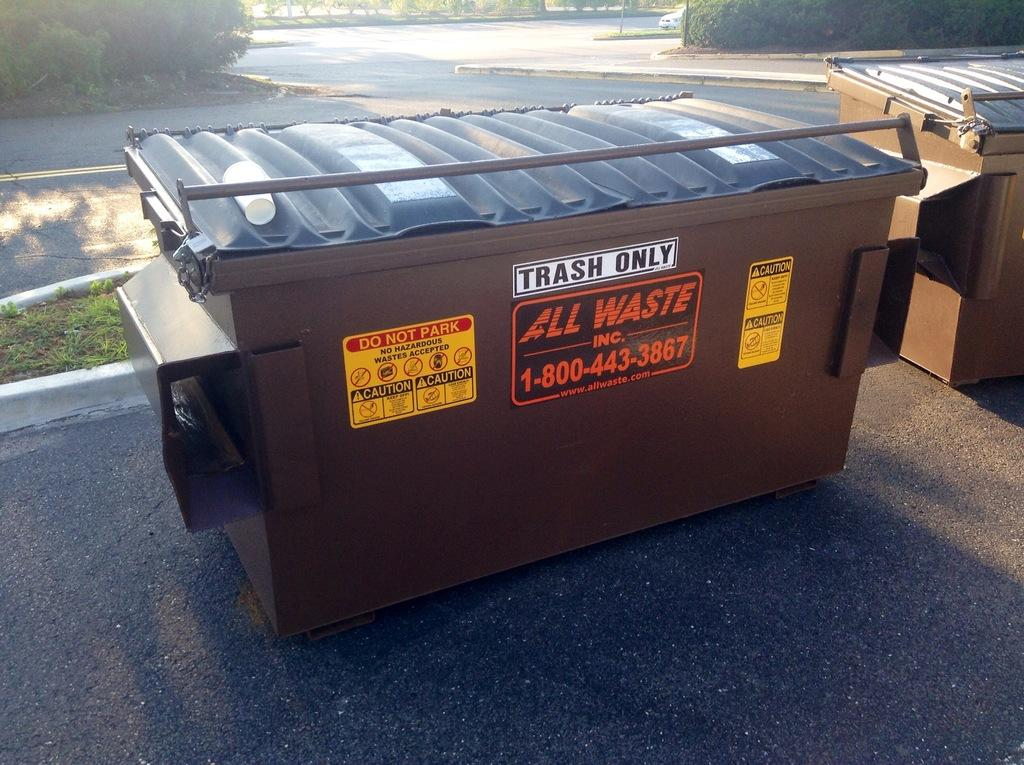<image>
Render a clear and concise summary of the photo. A dumpster from All Waste Incorporated has a sign on the front that says trash only. 